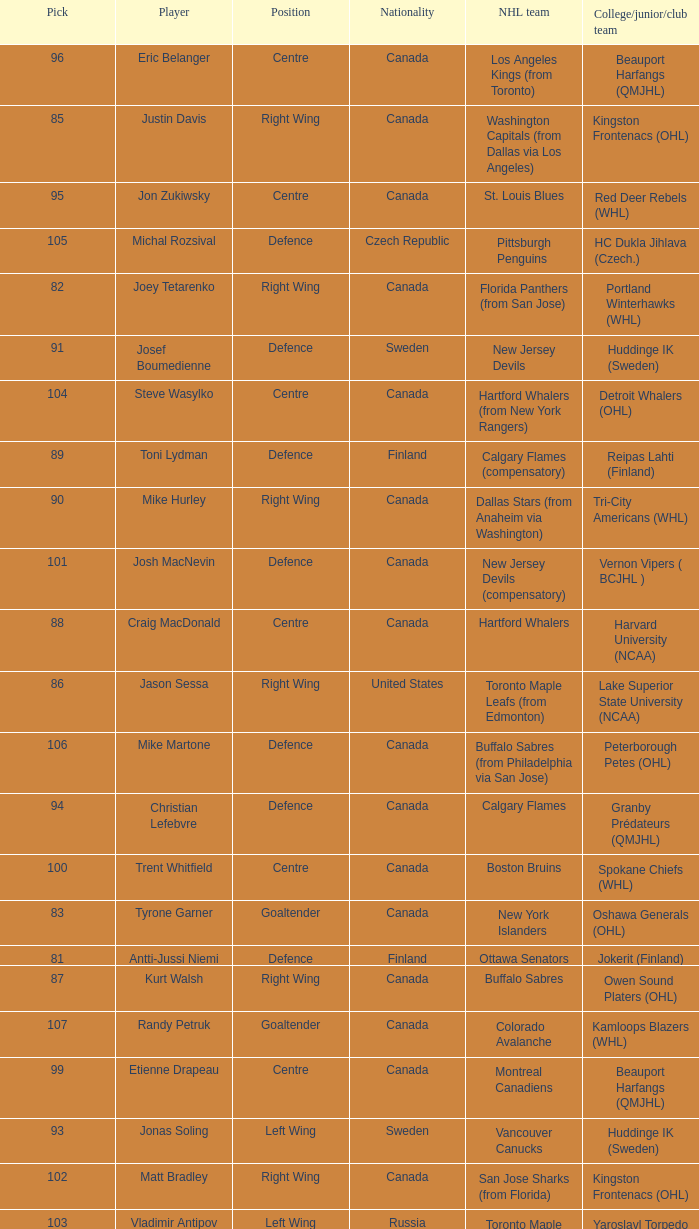How many draft pick positions did Matt Bradley have? 1.0. 